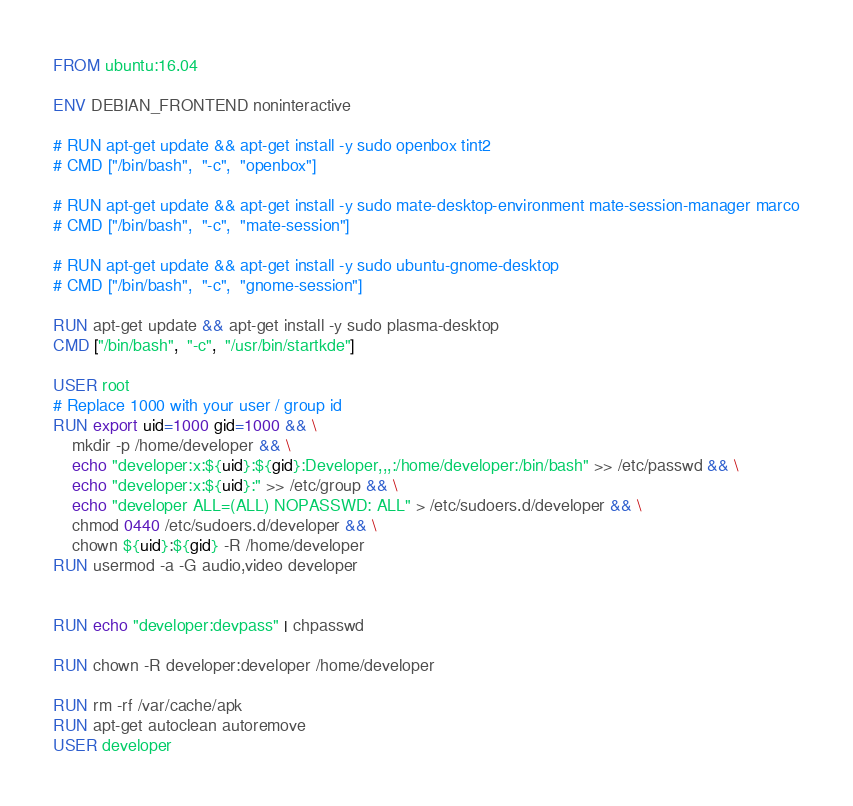<code> <loc_0><loc_0><loc_500><loc_500><_Dockerfile_>FROM ubuntu:16.04

ENV DEBIAN_FRONTEND noninteractive

# RUN apt-get update && apt-get install -y sudo openbox tint2
# CMD ["/bin/bash",  "-c",  "openbox"]

# RUN apt-get update && apt-get install -y sudo mate-desktop-environment mate-session-manager marco
# CMD ["/bin/bash",  "-c",  "mate-session"]

# RUN apt-get update && apt-get install -y sudo ubuntu-gnome-desktop
# CMD ["/bin/bash",  "-c",  "gnome-session"]

RUN apt-get update && apt-get install -y sudo plasma-desktop
CMD ["/bin/bash",  "-c",  "/usr/bin/startkde"]

USER root
# Replace 1000 with your user / group id
RUN export uid=1000 gid=1000 && \
    mkdir -p /home/developer && \
    echo "developer:x:${uid}:${gid}:Developer,,,:/home/developer:/bin/bash" >> /etc/passwd && \
    echo "developer:x:${uid}:" >> /etc/group && \
    echo "developer ALL=(ALL) NOPASSWD: ALL" > /etc/sudoers.d/developer && \
    chmod 0440 /etc/sudoers.d/developer && \
    chown ${uid}:${gid} -R /home/developer
RUN usermod -a -G audio,video developer


RUN echo "developer:devpass" | chpasswd

RUN chown -R developer:developer /home/developer

RUN rm -rf /var/cache/apk
RUN apt-get autoclean autoremove
USER developer

</code> 